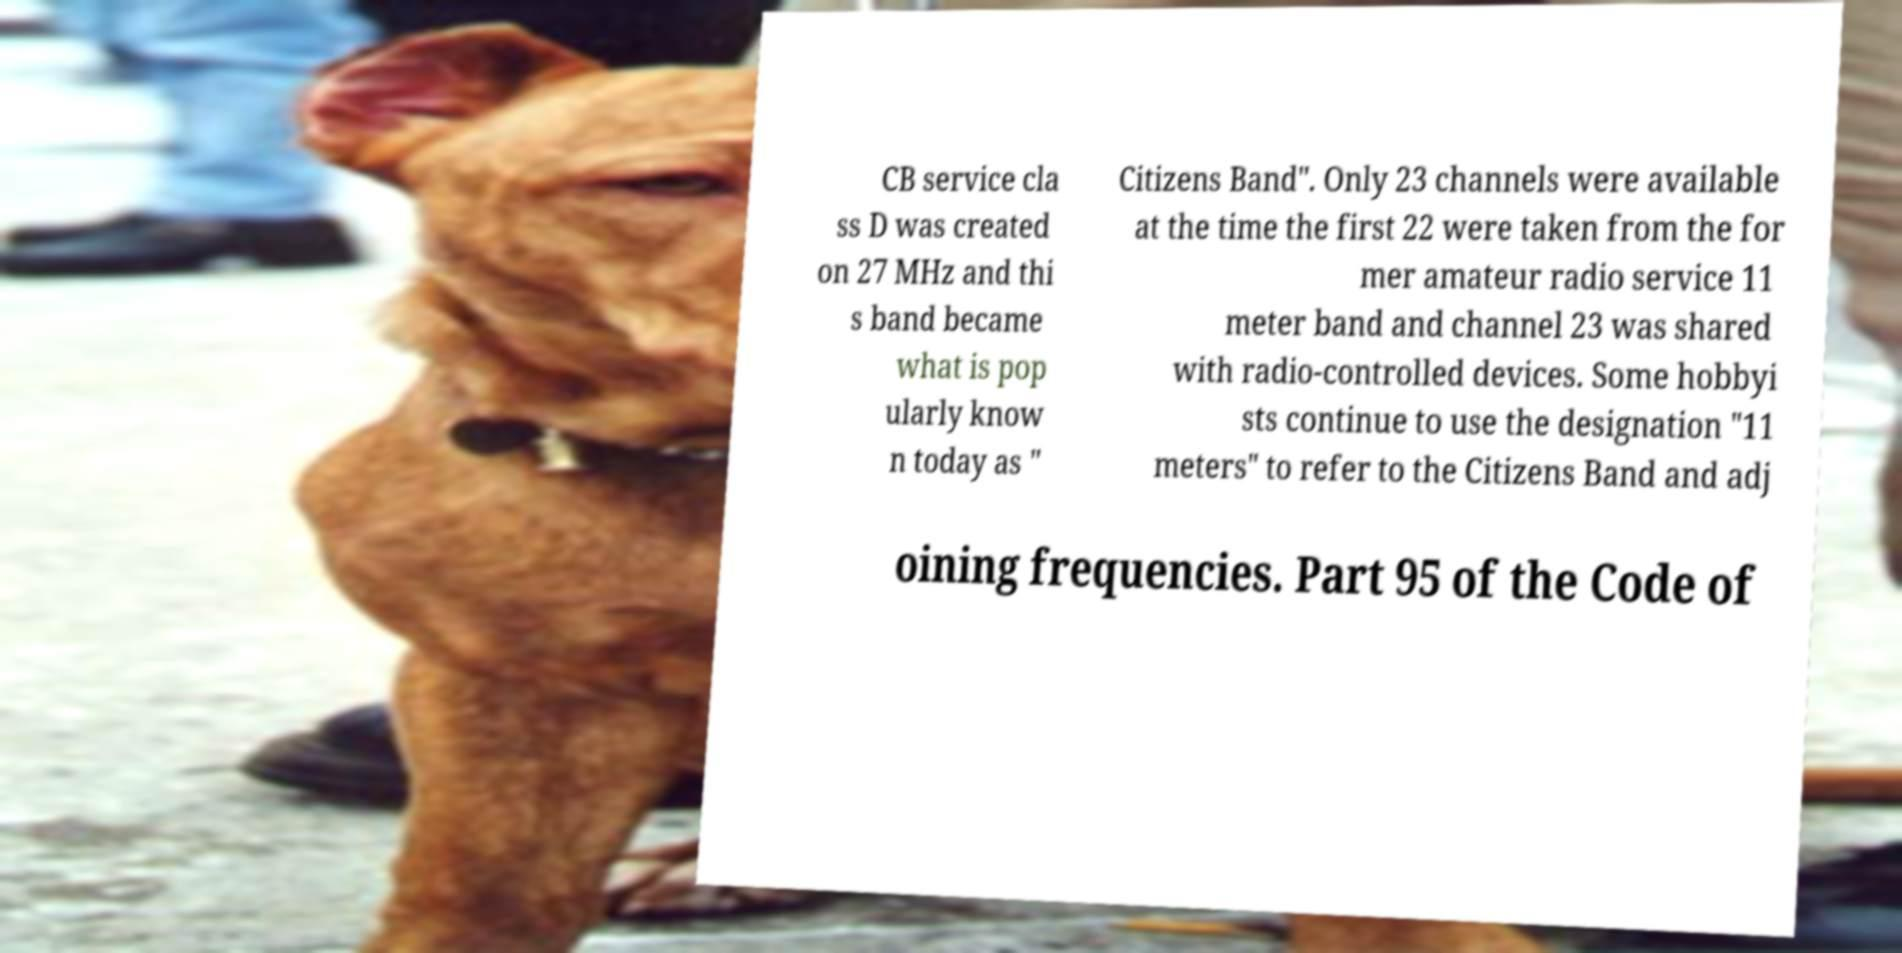Can you accurately transcribe the text from the provided image for me? CB service cla ss D was created on 27 MHz and thi s band became what is pop ularly know n today as " Citizens Band". Only 23 channels were available at the time the first 22 were taken from the for mer amateur radio service 11 meter band and channel 23 was shared with radio-controlled devices. Some hobbyi sts continue to use the designation "11 meters" to refer to the Citizens Band and adj oining frequencies. Part 95 of the Code of 